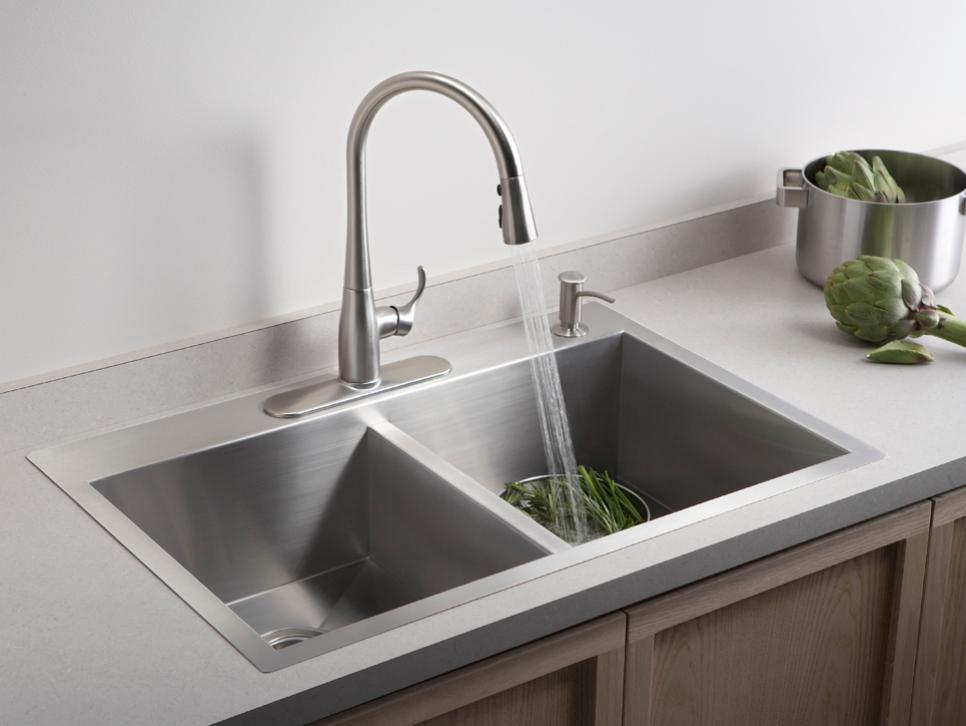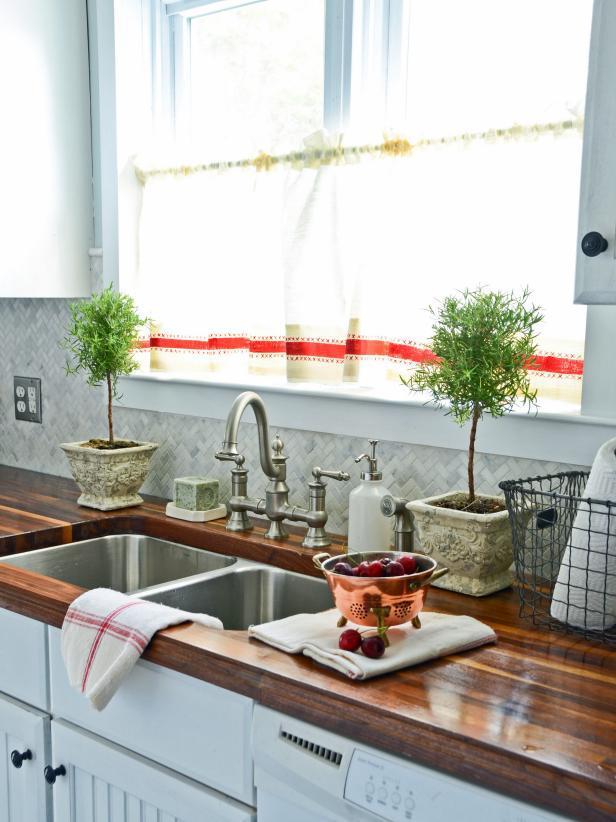The first image is the image on the left, the second image is the image on the right. For the images displayed, is the sentence "A large sink is surrounded by a marbled countertop." factually correct? Answer yes or no. No. 